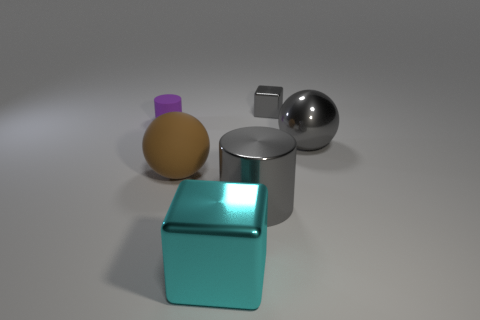Do the tiny block and the large cylinder have the same color?
Give a very brief answer. Yes. There is a sphere that is the same color as the tiny cube; what material is it?
Provide a succinct answer. Metal. There is a tiny cube; does it have the same color as the cylinder that is in front of the metal ball?
Your response must be concise. Yes. What material is the big thing that is both left of the gray shiny cube and right of the big cube?
Your answer should be compact. Metal. There is another thing that is the same shape as the tiny gray thing; what is its color?
Make the answer very short. Cyan. There is a ball that is right of the big brown object; are there any purple matte objects that are right of it?
Ensure brevity in your answer.  No. What size is the metal ball?
Ensure brevity in your answer.  Large. The gray thing that is behind the big brown object and left of the large gray metal sphere has what shape?
Offer a very short reply. Cube. What number of cyan objects are either large rubber spheres or spheres?
Provide a succinct answer. 0. Do the rubber cylinder behind the large block and the metal block behind the small purple matte cylinder have the same size?
Give a very brief answer. Yes. 